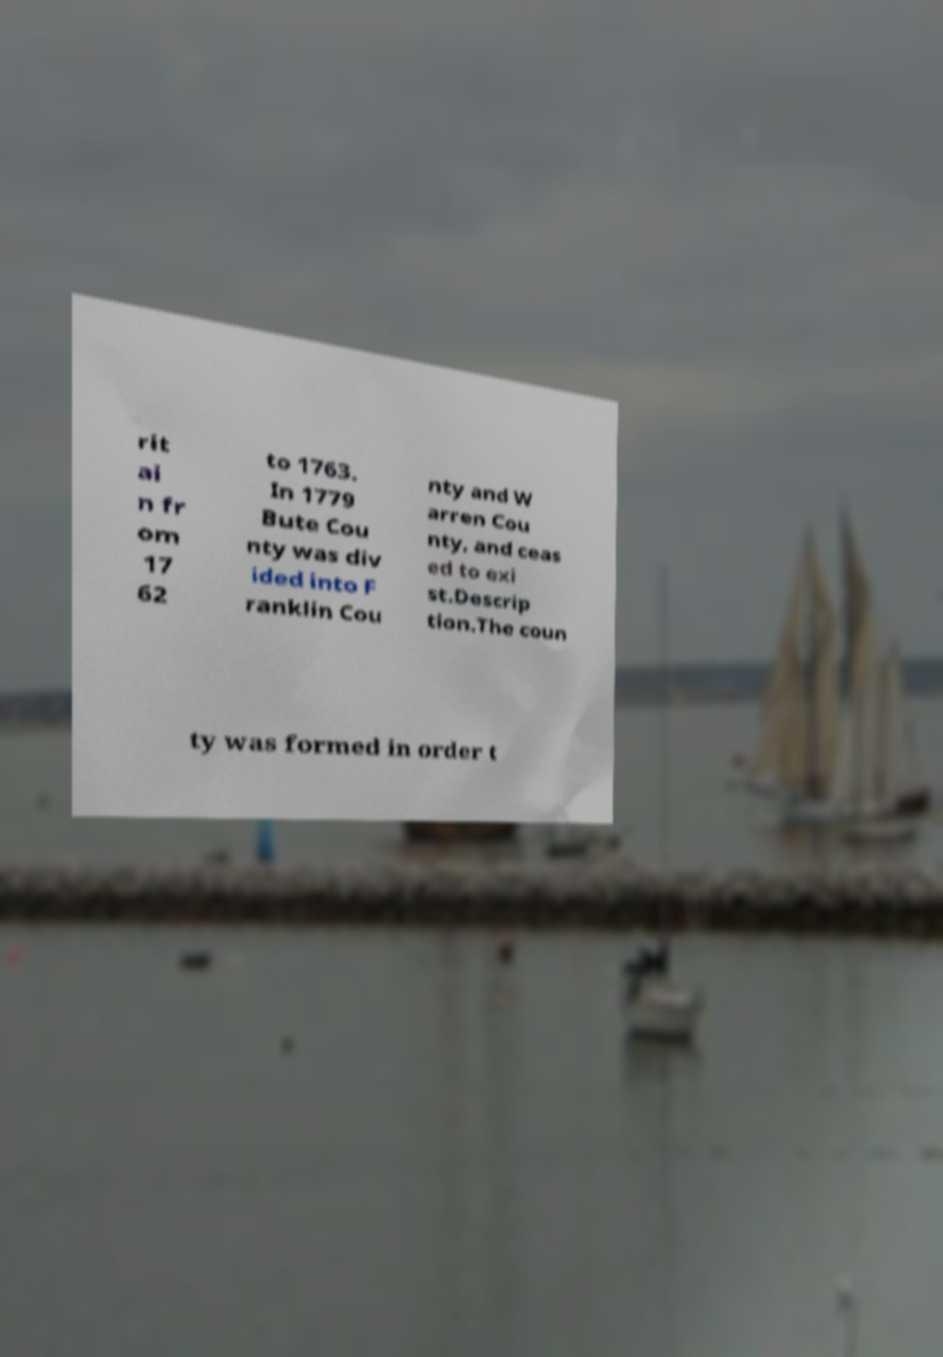Could you extract and type out the text from this image? rit ai n fr om 17 62 to 1763. In 1779 Bute Cou nty was div ided into F ranklin Cou nty and W arren Cou nty, and ceas ed to exi st.Descrip tion.The coun ty was formed in order t 